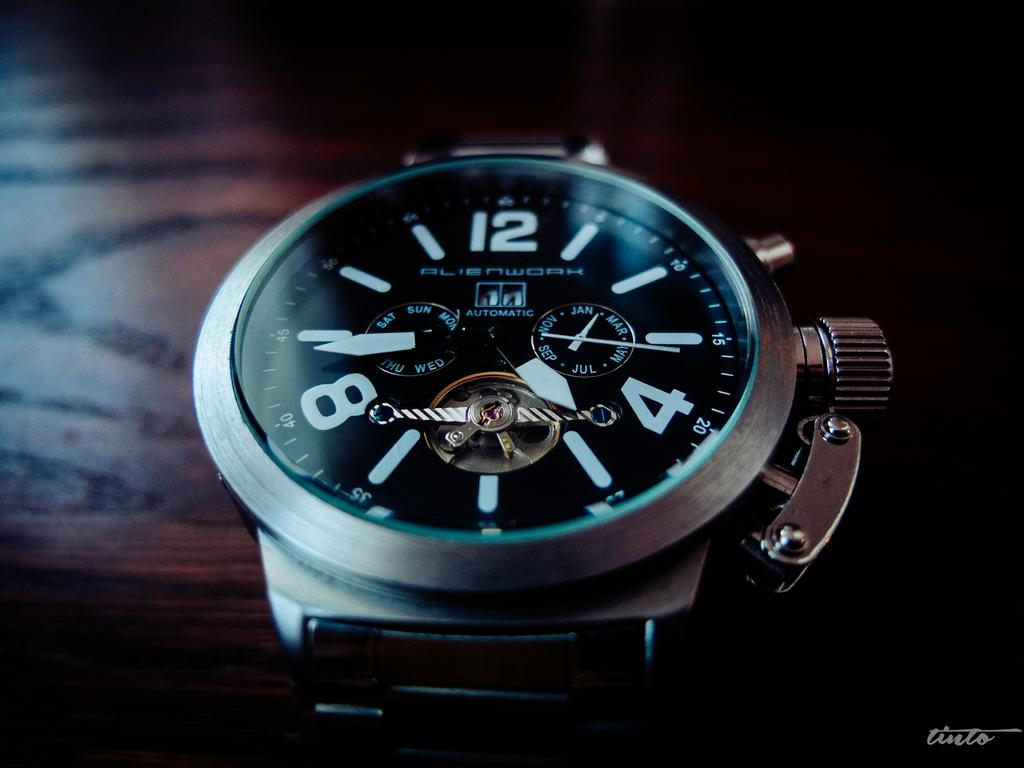<image>
Render a clear and concise summary of the photo. A black Alienwork brand watch that is automatic. 